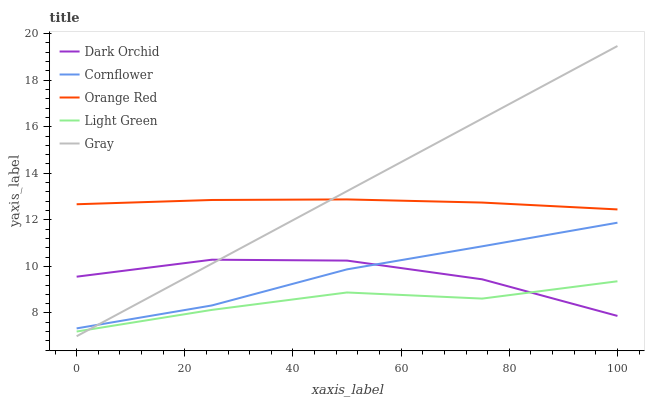Does Light Green have the minimum area under the curve?
Answer yes or no. Yes. Does Gray have the maximum area under the curve?
Answer yes or no. Yes. Does Orange Red have the minimum area under the curve?
Answer yes or no. No. Does Orange Red have the maximum area under the curve?
Answer yes or no. No. Is Gray the smoothest?
Answer yes or no. Yes. Is Dark Orchid the roughest?
Answer yes or no. Yes. Is Light Green the smoothest?
Answer yes or no. No. Is Light Green the roughest?
Answer yes or no. No. Does Light Green have the lowest value?
Answer yes or no. No. Does Orange Red have the highest value?
Answer yes or no. No. Is Dark Orchid less than Orange Red?
Answer yes or no. Yes. Is Cornflower greater than Light Green?
Answer yes or no. Yes. Does Dark Orchid intersect Orange Red?
Answer yes or no. No. 